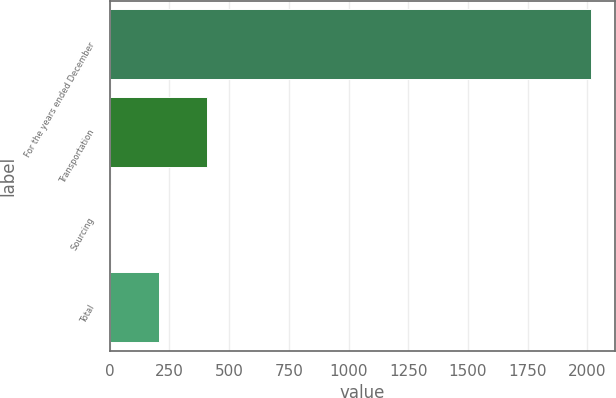<chart> <loc_0><loc_0><loc_500><loc_500><bar_chart><fcel>For the years ended December<fcel>Transportation<fcel>Sourcing<fcel>Total<nl><fcel>2014<fcel>408.8<fcel>7.5<fcel>208.15<nl></chart> 